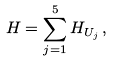<formula> <loc_0><loc_0><loc_500><loc_500>H = \sum _ { j = 1 } ^ { 5 } H _ { U _ { j } } \, ,</formula> 